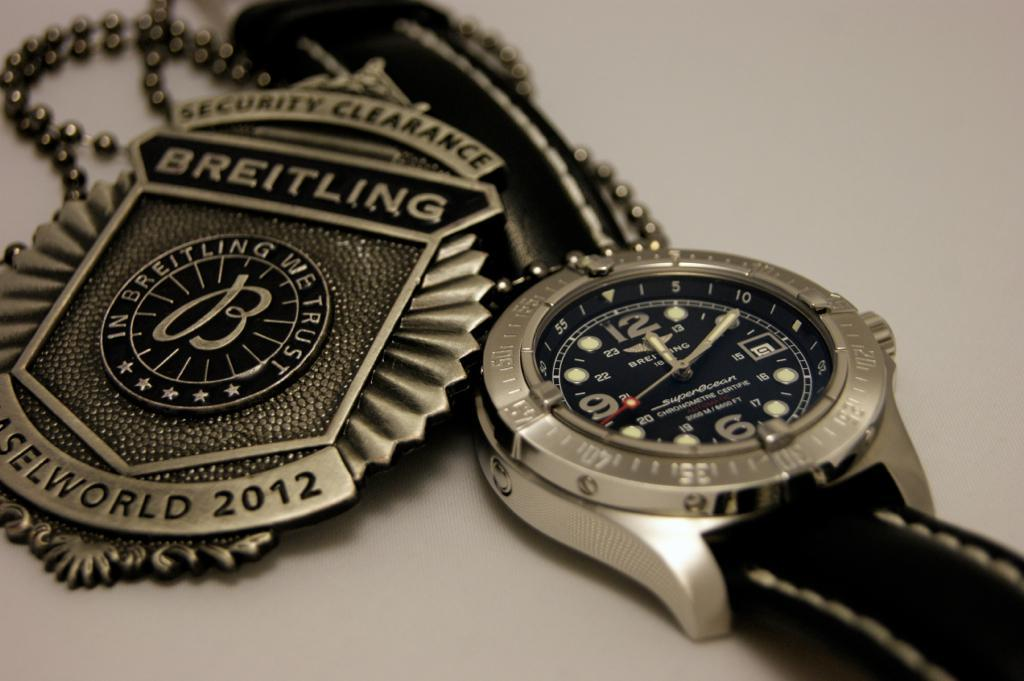<image>
Summarize the visual content of the image. a badge that says Breitling on the front 